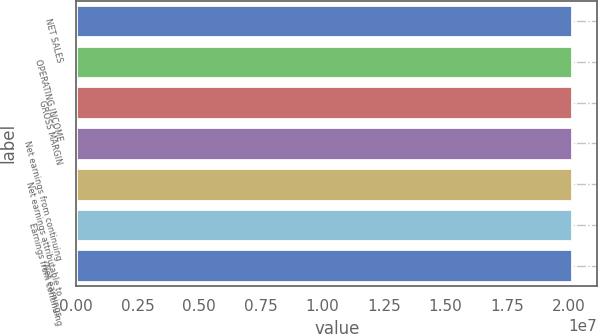Convert chart to OTSL. <chart><loc_0><loc_0><loc_500><loc_500><bar_chart><fcel>NET SALES<fcel>OPERATING INCOME<fcel>GROSS MARGIN<fcel>Net earnings from continuing<fcel>Net earnings attributable to<fcel>Earnings from continuing<fcel>Net earnings<nl><fcel>2.0162e+07<fcel>2.0162e+07<fcel>2.0162e+07<fcel>2.0162e+07<fcel>2.0162e+07<fcel>2.0162e+07<fcel>2.0162e+07<nl></chart> 